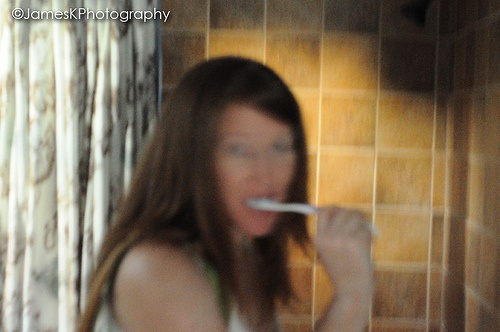Describe the objects in this image and their specific colors. I can see people in white, black, gray, and maroon tones and toothbrush in white, darkgray, and gray tones in this image. 